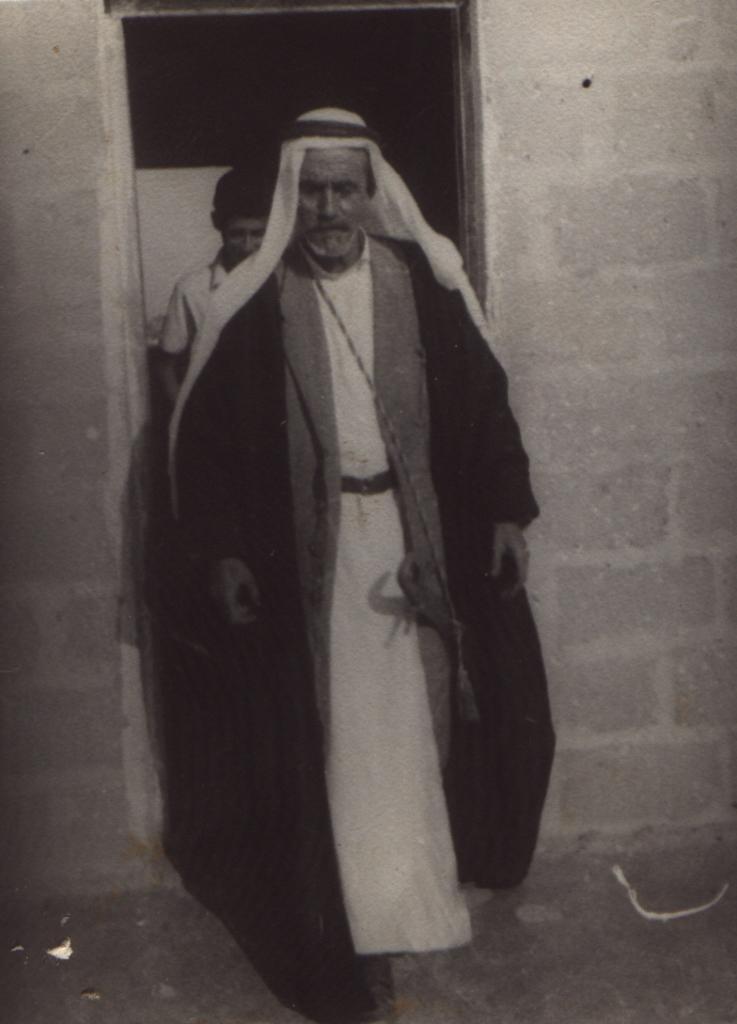How would you summarize this image in a sentence or two? This is a black and white image and here we can see a person wearing a coat and a kurta and a head turban. In the background, there is another person and we can see a wall. 